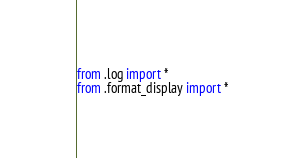Convert code to text. <code><loc_0><loc_0><loc_500><loc_500><_Python_>from .log import *
from .format_display import *</code> 